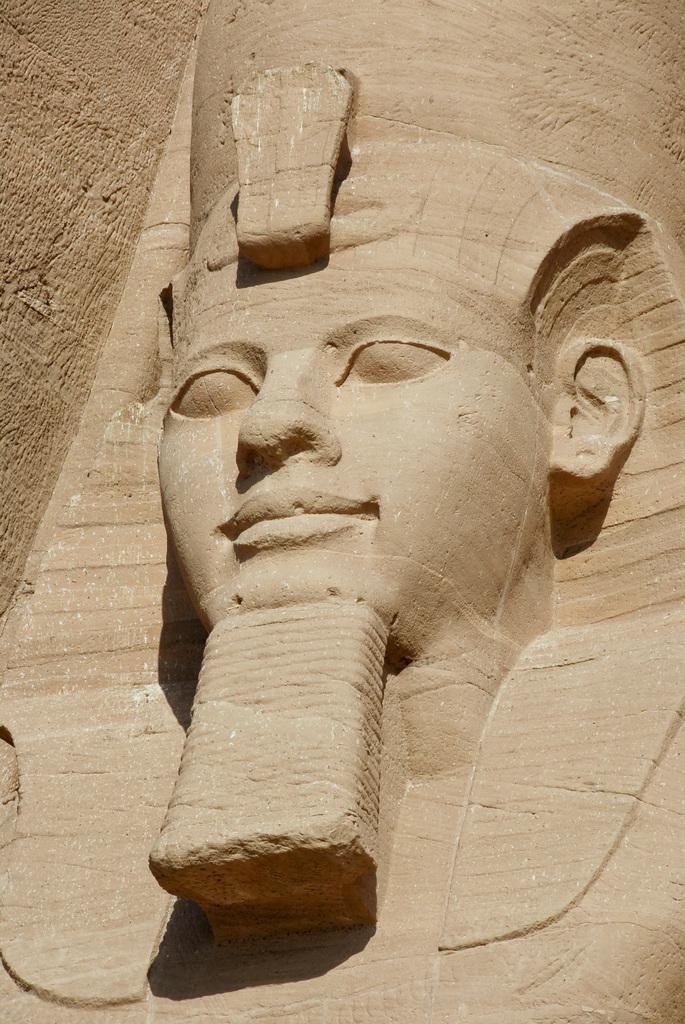Describe this image in one or two sentences. In this image in the center there is a sculpture, and in the background it looks like a wall. 